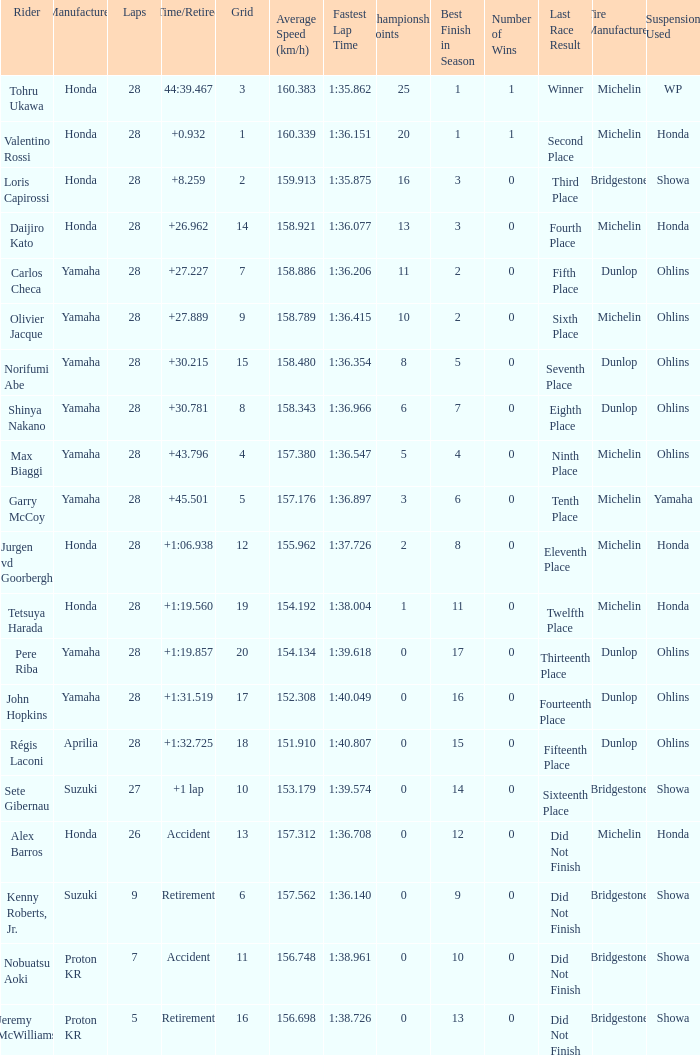What was the total number of laps completed by pere riba? 28.0. Can you parse all the data within this table? {'header': ['Rider', 'Manufacturer', 'Laps', 'Time/Retired', 'Grid', 'Average Speed (km/h)', 'Fastest Lap Time', 'Championship Points', 'Best Finish in Season', 'Number of Wins', 'Last Race Result', 'Tire Manufacturer', 'Suspension Used '], 'rows': [['Tohru Ukawa', 'Honda', '28', '44:39.467', '3', '160.383', '1:35.862', '25', '1', '1', 'Winner', 'Michelin', 'WP'], ['Valentino Rossi', 'Honda', '28', '+0.932', '1', '160.339', '1:36.151', '20', '1', '1', 'Second Place', 'Michelin', 'Honda'], ['Loris Capirossi', 'Honda', '28', '+8.259', '2', '159.913', '1:35.875', '16', '3', '0', 'Third Place', 'Bridgestone', 'Showa'], ['Daijiro Kato', 'Honda', '28', '+26.962', '14', '158.921', '1:36.077', '13', '3', '0', 'Fourth Place', 'Michelin', 'Honda'], ['Carlos Checa', 'Yamaha', '28', '+27.227', '7', '158.886', '1:36.206', '11', '2', '0', 'Fifth Place', 'Dunlop', 'Ohlins'], ['Olivier Jacque', 'Yamaha', '28', '+27.889', '9', '158.789', '1:36.415', '10', '2', '0', 'Sixth Place', 'Michelin', 'Ohlins'], ['Norifumi Abe', 'Yamaha', '28', '+30.215', '15', '158.480', '1:36.354', '8', '5', '0', 'Seventh Place', 'Dunlop', 'Ohlins'], ['Shinya Nakano', 'Yamaha', '28', '+30.781', '8', '158.343', '1:36.966', '6', '7', '0', 'Eighth Place', 'Dunlop', 'Ohlins'], ['Max Biaggi', 'Yamaha', '28', '+43.796', '4', '157.380', '1:36.547', '5', '4', '0', 'Ninth Place', 'Michelin', 'Ohlins'], ['Garry McCoy', 'Yamaha', '28', '+45.501', '5', '157.176', '1:36.897', '3', '6', '0', 'Tenth Place', 'Michelin', 'Yamaha'], ['Jurgen vd Goorbergh', 'Honda', '28', '+1:06.938', '12', '155.962', '1:37.726', '2', '8', '0', 'Eleventh Place', 'Michelin', 'Honda'], ['Tetsuya Harada', 'Honda', '28', '+1:19.560', '19', '154.192', '1:38.004', '1', '11', '0', 'Twelfth Place', 'Michelin', 'Honda'], ['Pere Riba', 'Yamaha', '28', '+1:19.857', '20', '154.134', '1:39.618', '0', '17', '0', 'Thirteenth Place', 'Dunlop', 'Ohlins'], ['John Hopkins', 'Yamaha', '28', '+1:31.519', '17', '152.308', '1:40.049', '0', '16', '0', 'Fourteenth Place', 'Dunlop', 'Ohlins'], ['Régis Laconi', 'Aprilia', '28', '+1:32.725', '18', '151.910', '1:40.807', '0', '15', '0', 'Fifteenth Place', 'Dunlop', 'Ohlins'], ['Sete Gibernau', 'Suzuki', '27', '+1 lap', '10', '153.179', '1:39.574', '0', '14', '0', 'Sixteenth Place', 'Bridgestone', 'Showa'], ['Alex Barros', 'Honda', '26', 'Accident', '13', '157.312', '1:36.708', '0', '12', '0', 'Did Not Finish', 'Michelin', 'Honda'], ['Kenny Roberts, Jr.', 'Suzuki', '9', 'Retirement', '6', '157.562', '1:36.140', '0', '9', '0', 'Did Not Finish', 'Bridgestone', 'Showa'], ['Nobuatsu Aoki', 'Proton KR', '7', 'Accident', '11', '156.748', '1:38.961', '0', '10', '0', 'Did Not Finish', 'Bridgestone', 'Showa'], ['Jeremy McWilliams', 'Proton KR', '5', 'Retirement', '16', '156.698', '1:38.726', '0', '13', '0', 'Did Not Finish', 'Bridgestone', 'Showa']]} 